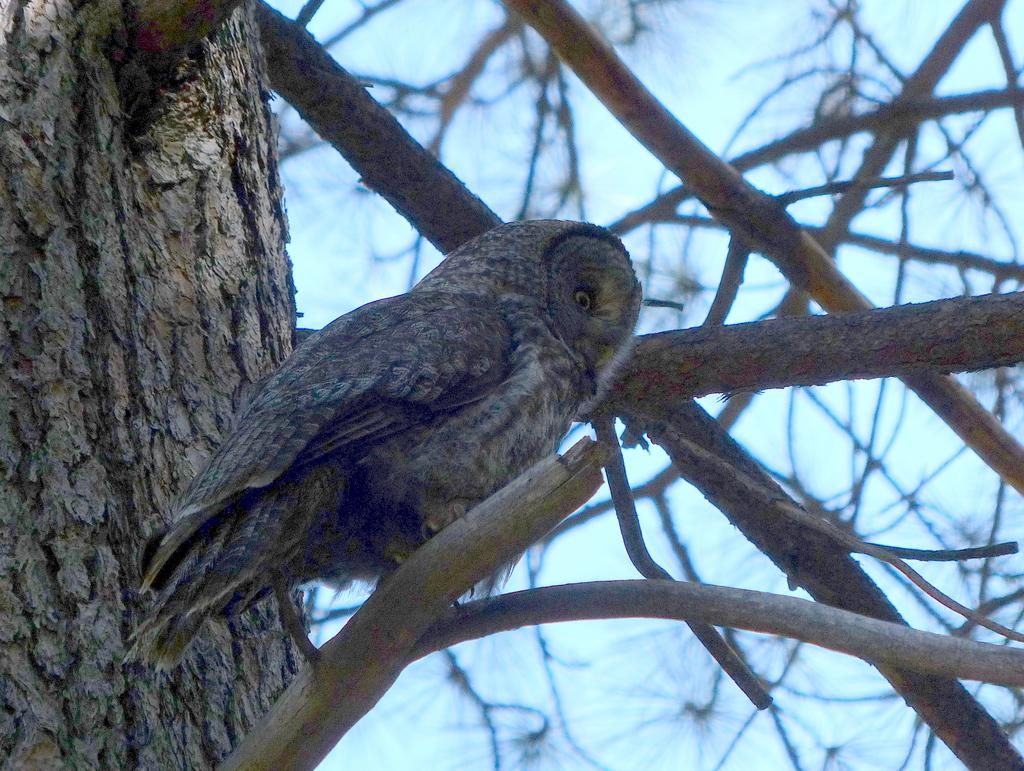What type of animal can be seen in the image? There is a bird in the image. Where is the bird located? The bird is on a branch. What can be seen on the left side of the image? There is a tree trunk on the left side of the image. What is present on the right side of the image? There are branches on the right side of the image. What is visible in the background of the image? The sky is visible in the background of the image. What letter can be seen on the bird's wing in the image? There is no letter visible on the bird's wing in the image. Is there a source of water visible in the image? There is no water present in the image. 